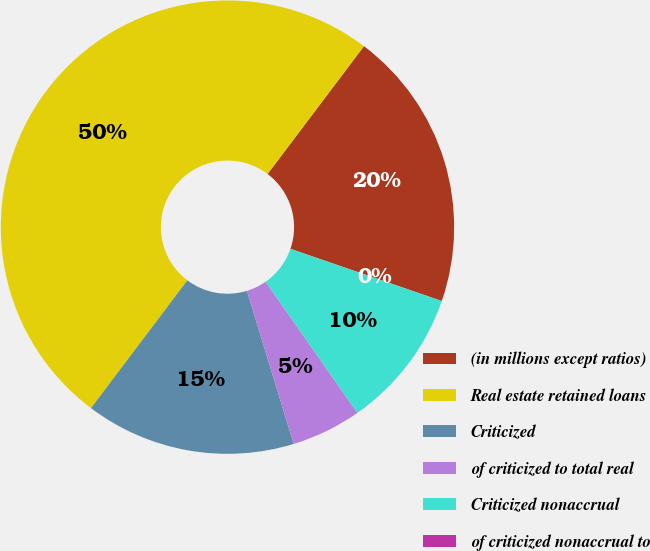Convert chart. <chart><loc_0><loc_0><loc_500><loc_500><pie_chart><fcel>(in millions except ratios)<fcel>Real estate retained loans<fcel>Criticized<fcel>of criticized to total real<fcel>Criticized nonaccrual<fcel>of criticized nonaccrual to<nl><fcel>20.0%<fcel>50.0%<fcel>15.0%<fcel>5.0%<fcel>10.0%<fcel>0.0%<nl></chart> 